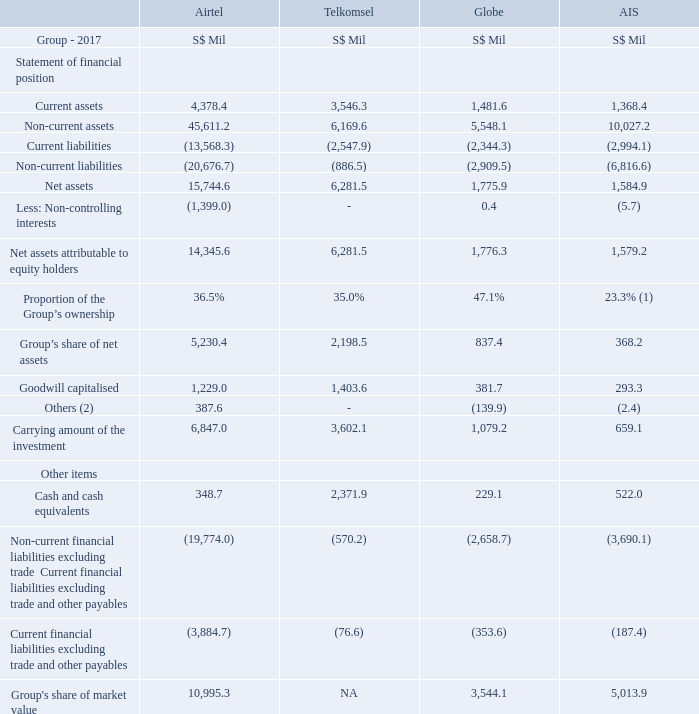22. JOINT VENTURES (Cont’d)
‘‘NA’’ denotes Not Applicable.
Notes:
(1) Based on the Group’s direct equity interest in AIS.
(2) Others include adjustments to align the respective local accounting standards to SFRS(I).
What is the topic of note 22? Joint ventures. What does the line item "Others" in the table encompass? Adjustments to align the respective local accounting standards to sfrs(i). Does the 23.3% of the group's ownership in AIS include any indirect equity interest? No. Which is the largest joint venture of Singtel, in terms of the proportion of Group's ownership? 47.1 > 36.5 > 35.0 > 23.3
Answer: globe. Which is the largest joint venture of Singtel, in terms of the carrying amount of investment? 6,847.0 > 3,602.1 > 1,079.2 > 659.1
Answer: airtel. For the joint venture with Airtel, what is the financial impact of the non-controlling interests on the group's share of net assets?
Answer scale should be: million. 1,399.0 * 36.5%
Answer: 510.63. 